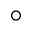Convert formula to latex. <formula><loc_0><loc_0><loc_500><loc_500>\circ</formula> 